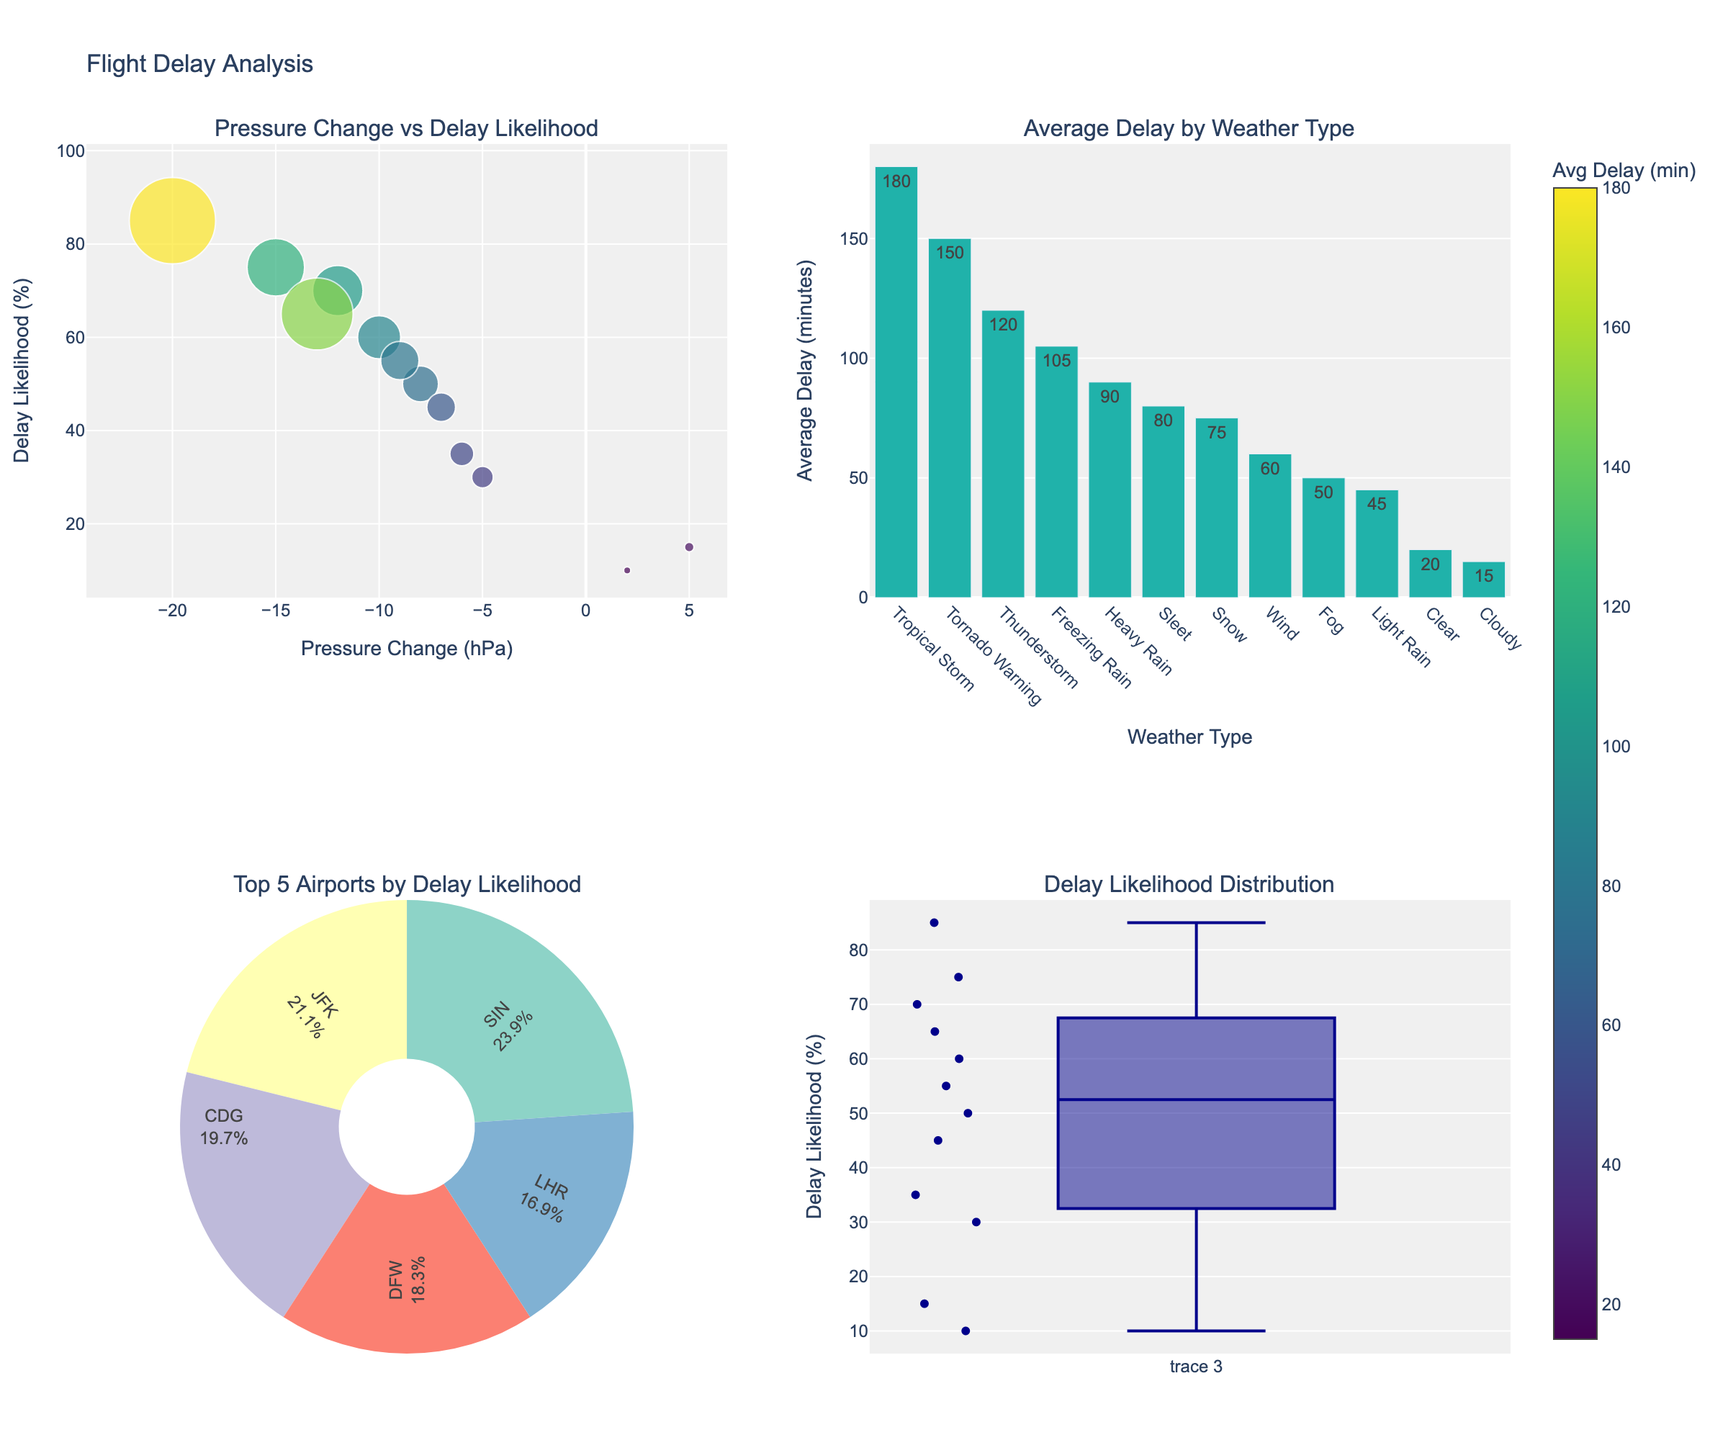What's the title of the figure? The title is located at the top of the figure. It generally summarizes what the entire figure represents.
Answer: Flight Delay Analysis How many airports have their Delay Likelihood greater than 50%? Look at the scatter plot where the y-axis represents Delay Likelihood (%). Count how many data points (markers) are above the 50% mark.
Answer: 6 Which airport has the highest average delay time, and what is the weather type associated with it? In the scatter plot, the size of the markers represents the average delay time in minutes. Identify the largest marker. The largest marker here is for SIN. Then, correlate with the data in the dataset to find that the weather type is Tropical Storm.
Answer: SIN, Tropical Storm What is the pressure change in hPa for LHR airport, and how does that affect its delay likelihood? On the scatter plot, find the data point that corresponds to LHR. The x-axis shows the Pressure Change in hPa, and the y-axis shows the Delay Likelihood in %. LHR is at -10 hPa and 60% delay likelihood.
Answer: -10 hPa, 60% Which weather type results in the highest average delay, and what is that delay? Refer to the bar chart that plots average delay times by weather type. The tallest bar indicates the highest average delay. The weather type associated with it is Tornado Warning.
Answer: Tornado Warning, 150 minutes How are the top five airports distributed in terms of Delay Likelihood? Look at the pie chart. The top five airports are represented by each slice, with their delay likelihood % shown as part of the labels.
Answer: Distribution among JFK, SIN, CDG, DFW, and LHR Which airport has the lowest Delay Likelihood % and what is the corresponding Avg Delay in minutes? From the scatter plot, find the data point with the lowest position on the y-axis. This corresponds to HND. The label will show its Avg Delay as well.
Answer: HND, 15 minutes What is the median Delay Likelihood % for all airports? Refer to the box plot in the bottom-right. The middle line inside the box represents the median value.
Answer: 50% How does the pressure change correlate with delay likelihood for the airport with the 3rd highest delay likelihood? Identify the 3rd highest delay likelihood from either the scatter plot or pie chart, which is associated with CDG. Look at the x-axis value for CDG to find the Pressure Change. CDG has a pressure change of -12 hPa and 70% delay likelihood.
Answer: -12 hPa, 70% Compare the average delay in minutes for Thunderstorm and Heavy Rain. Which has a higher delay and by how much? Using the bar chart, find the average delay for both Thunderstorm and Heavy Rain and subtract the values to find the difference. Thunderstorm has an average delay of 120 minutes, while Heavy Rain has 90 minutes, leading to a difference of 30 minutes.
Answer: Thunderstorm, by 30 minutes 